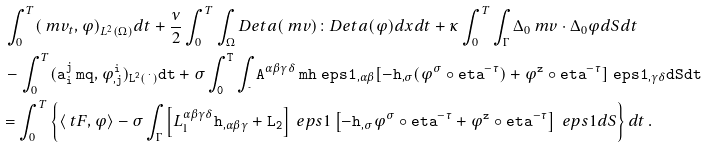Convert formula to latex. <formula><loc_0><loc_0><loc_500><loc_500>& \ \int _ { 0 } ^ { T } ( \ m v _ { t } , \varphi ) _ { L ^ { 2 } ( \Omega ) } d t + \frac { \nu } { 2 } \int _ { 0 } ^ { T } \int _ { \Omega } D _ { \tt } e t a ( \ m v ) \colon D _ { \tt } e t a ( \varphi ) d x d t + \kappa \int _ { 0 } ^ { T } \int _ { \Gamma } \Delta _ { 0 } \ m v \cdot \Delta _ { 0 } \varphi d S d t \\ & \ - \int _ { 0 } ^ { T } ( \tt a ^ { j } _ { i } \ m q , \varphi ^ { i } _ { , j } ) _ { L ^ { 2 } ( \Omega ) } d t + \sigma \int _ { 0 } ^ { T } \int _ { \Gamma } \tt A ^ { \alpha \beta \gamma \delta } \ m h ^ { \ } e p s 1 _ { , \alpha \beta } [ - \tt h _ { , \sigma } ( \varphi ^ { \sigma } \circ \tt e t a ^ { - \tau } ) + \varphi ^ { z } \circ \tt e t a ^ { - \tau } ] ^ { \ } e p s 1 _ { , \gamma \delta } d S d t \\ & = \int _ { 0 } ^ { T } \left \{ \langle \ t F , \varphi \rangle - \sigma \int _ { \Gamma } \left [ L _ { 1 } ^ { \alpha \beta \gamma \delta } \tt h _ { , \alpha \beta \gamma } + L _ { 2 } \right ] ^ { \ } e p s 1 \left [ - \tt h _ { , \sigma } \varphi ^ { \sigma } \circ \tt e t a ^ { - \tau } + \varphi ^ { z } \circ \tt e t a ^ { - \tau } \right ] ^ { \ } e p s 1 d S \right \} d t \, .</formula> 